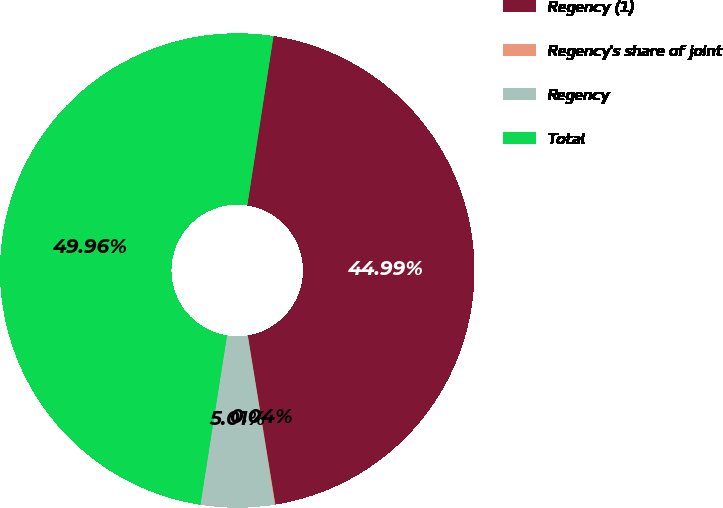Convert chart. <chart><loc_0><loc_0><loc_500><loc_500><pie_chart><fcel>Regency (1)<fcel>Regency's share of joint<fcel>Regency<fcel>Total<nl><fcel>44.99%<fcel>0.04%<fcel>5.01%<fcel>49.96%<nl></chart> 